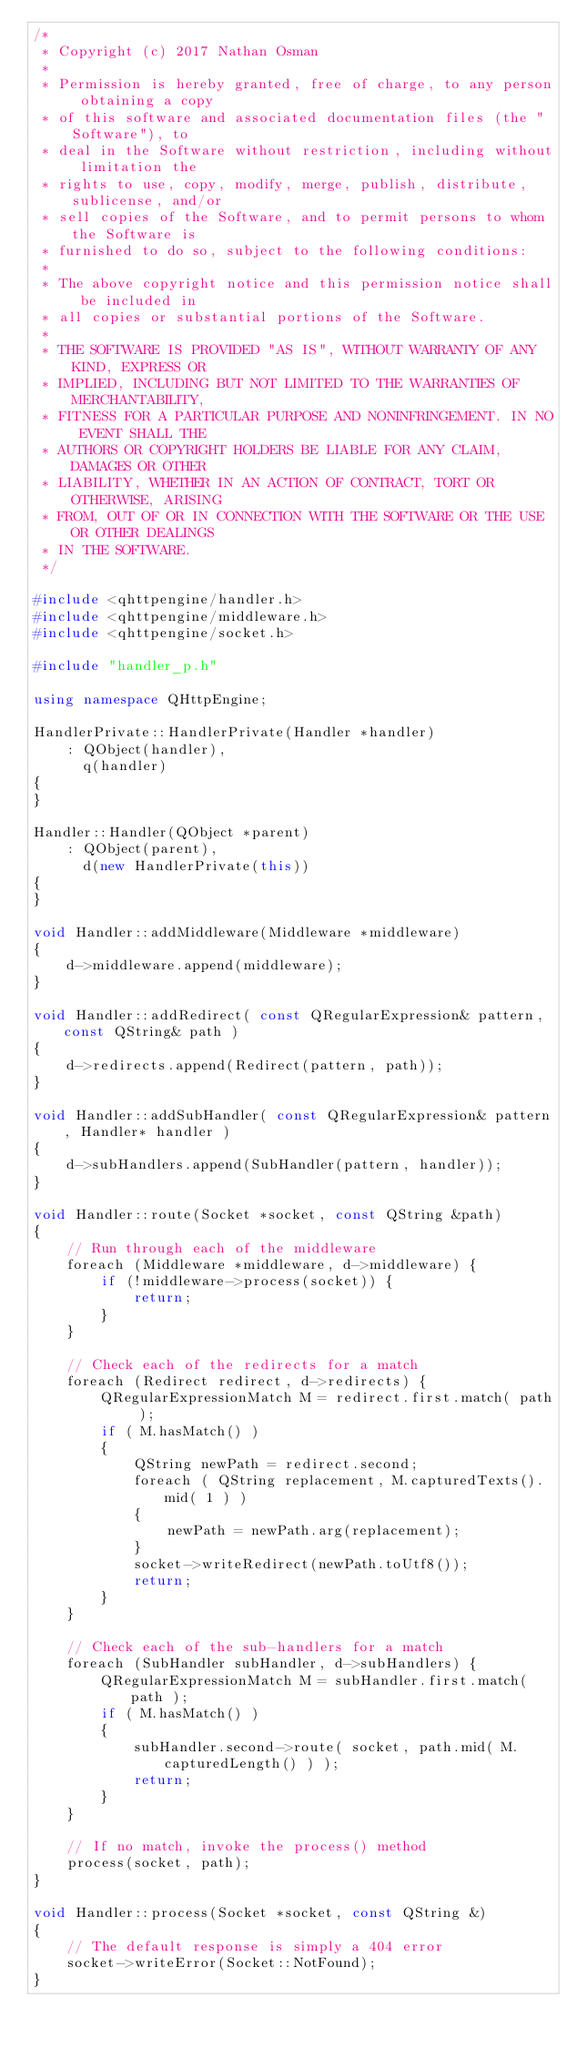<code> <loc_0><loc_0><loc_500><loc_500><_C++_>/*
 * Copyright (c) 2017 Nathan Osman
 *
 * Permission is hereby granted, free of charge, to any person obtaining a copy
 * of this software and associated documentation files (the "Software"), to
 * deal in the Software without restriction, including without limitation the
 * rights to use, copy, modify, merge, publish, distribute, sublicense, and/or
 * sell copies of the Software, and to permit persons to whom the Software is
 * furnished to do so, subject to the following conditions:
 *
 * The above copyright notice and this permission notice shall be included in
 * all copies or substantial portions of the Software.
 *
 * THE SOFTWARE IS PROVIDED "AS IS", WITHOUT WARRANTY OF ANY KIND, EXPRESS OR
 * IMPLIED, INCLUDING BUT NOT LIMITED TO THE WARRANTIES OF MERCHANTABILITY,
 * FITNESS FOR A PARTICULAR PURPOSE AND NONINFRINGEMENT. IN NO EVENT SHALL THE
 * AUTHORS OR COPYRIGHT HOLDERS BE LIABLE FOR ANY CLAIM, DAMAGES OR OTHER
 * LIABILITY, WHETHER IN AN ACTION OF CONTRACT, TORT OR OTHERWISE, ARISING
 * FROM, OUT OF OR IN CONNECTION WITH THE SOFTWARE OR THE USE OR OTHER DEALINGS
 * IN THE SOFTWARE.
 */

#include <qhttpengine/handler.h>
#include <qhttpengine/middleware.h>
#include <qhttpengine/socket.h>

#include "handler_p.h"

using namespace QHttpEngine;

HandlerPrivate::HandlerPrivate(Handler *handler)
    : QObject(handler),
      q(handler)
{
}

Handler::Handler(QObject *parent)
    : QObject(parent),
      d(new HandlerPrivate(this))
{
}

void Handler::addMiddleware(Middleware *middleware)
{
    d->middleware.append(middleware);
}

void Handler::addRedirect( const QRegularExpression& pattern, const QString& path )
{
    d->redirects.append(Redirect(pattern, path));
}

void Handler::addSubHandler( const QRegularExpression& pattern, Handler* handler )
{
    d->subHandlers.append(SubHandler(pattern, handler));
}

void Handler::route(Socket *socket, const QString &path)
{
    // Run through each of the middleware
    foreach (Middleware *middleware, d->middleware) {
        if (!middleware->process(socket)) {
            return;
        }
    }

    // Check each of the redirects for a match
    foreach (Redirect redirect, d->redirects) {
        QRegularExpressionMatch M = redirect.first.match( path );
        if ( M.hasMatch() )
        {
            QString newPath = redirect.second;
            foreach ( QString replacement, M.capturedTexts().mid( 1 ) )
            {
                newPath = newPath.arg(replacement);
            }
            socket->writeRedirect(newPath.toUtf8());
            return;
        }
    }

    // Check each of the sub-handlers for a match
    foreach (SubHandler subHandler, d->subHandlers) {
        QRegularExpressionMatch M = subHandler.first.match( path );
        if ( M.hasMatch() )
        {
            subHandler.second->route( socket, path.mid( M.capturedLength() ) );
            return;
        }
    }

    // If no match, invoke the process() method
    process(socket, path);
}

void Handler::process(Socket *socket, const QString &)
{
    // The default response is simply a 404 error
    socket->writeError(Socket::NotFound);
}
</code> 